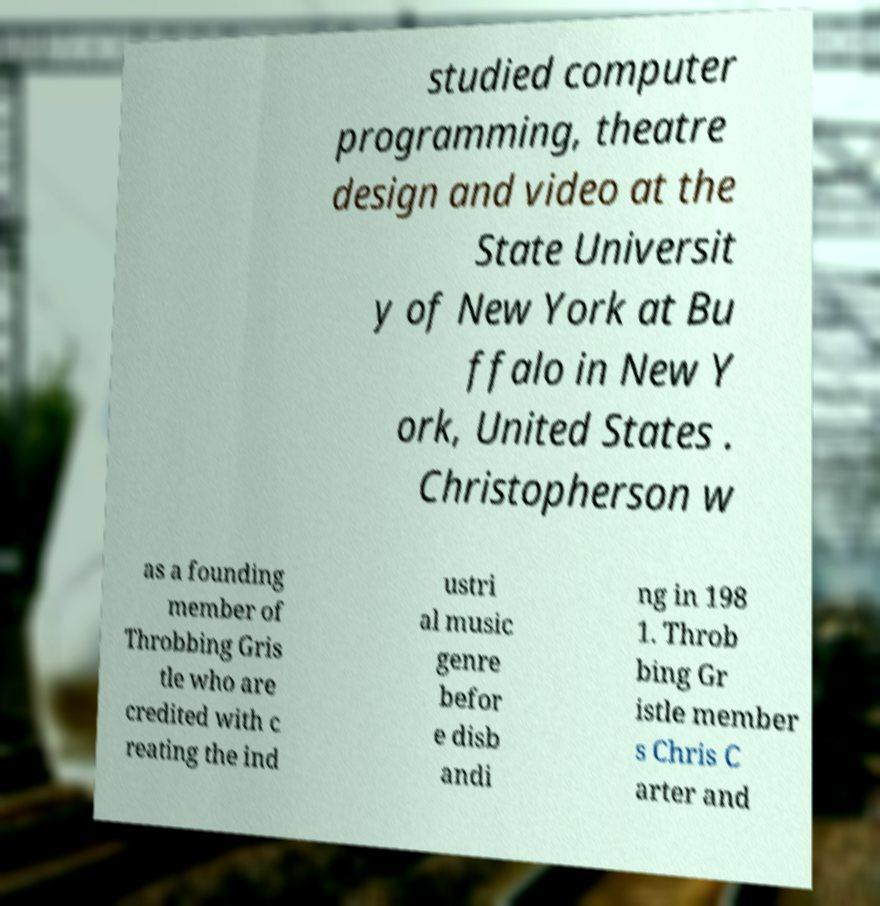Could you extract and type out the text from this image? studied computer programming, theatre design and video at the State Universit y of New York at Bu ffalo in New Y ork, United States . Christopherson w as a founding member of Throbbing Gris tle who are credited with c reating the ind ustri al music genre befor e disb andi ng in 198 1. Throb bing Gr istle member s Chris C arter and 